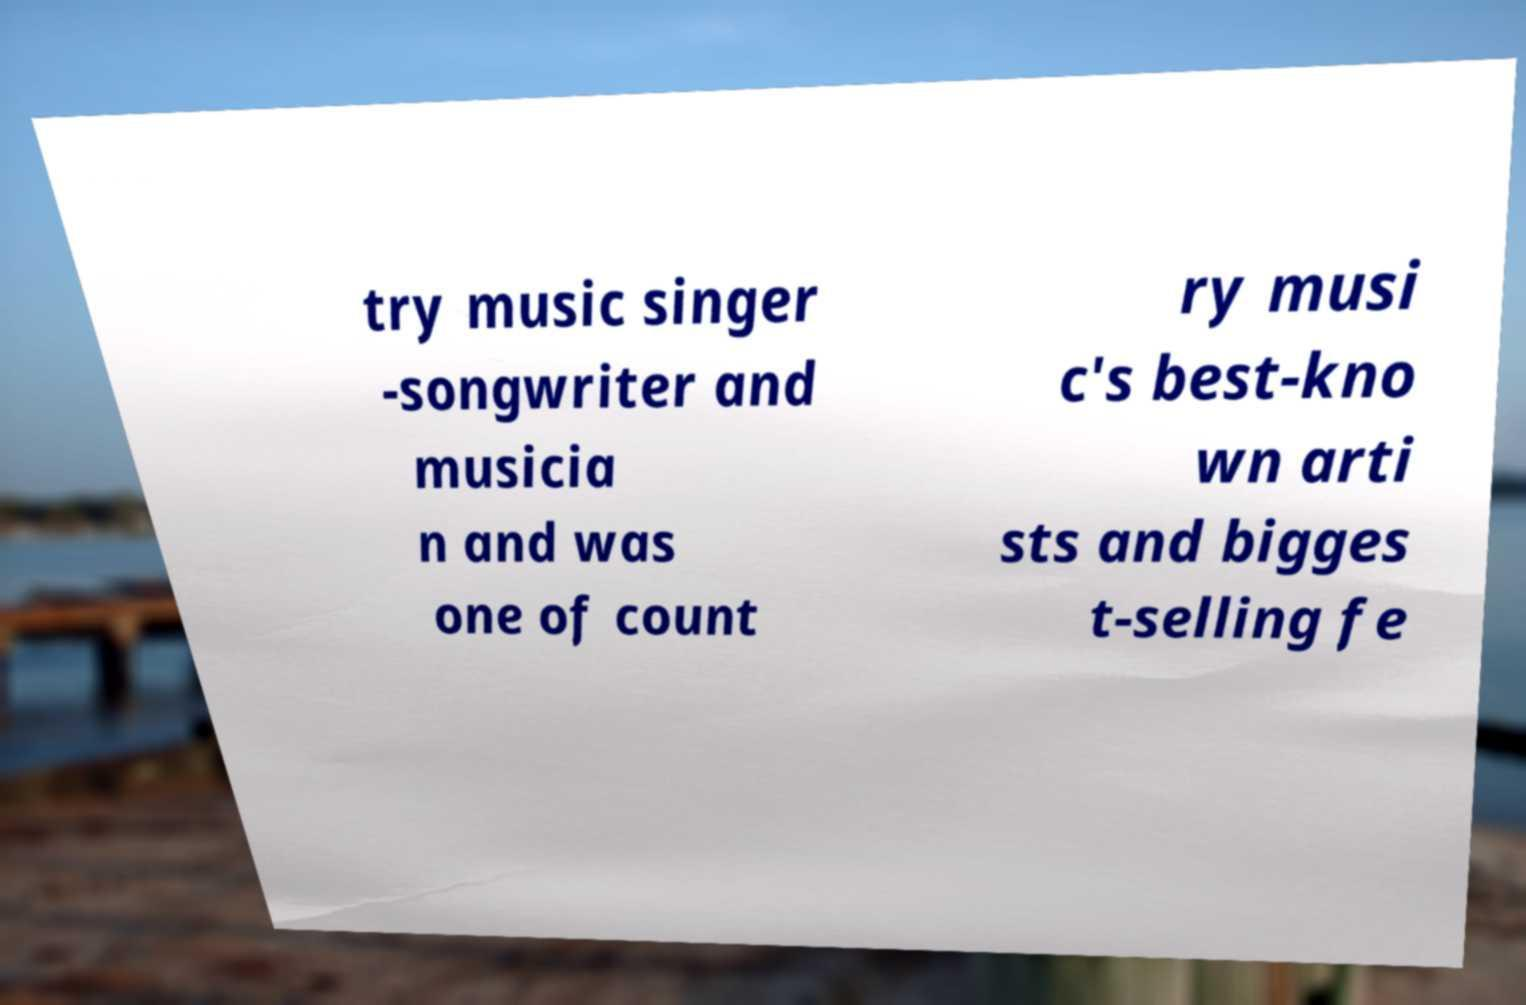Please read and relay the text visible in this image. What does it say? try music singer -songwriter and musicia n and was one of count ry musi c's best-kno wn arti sts and bigges t-selling fe 